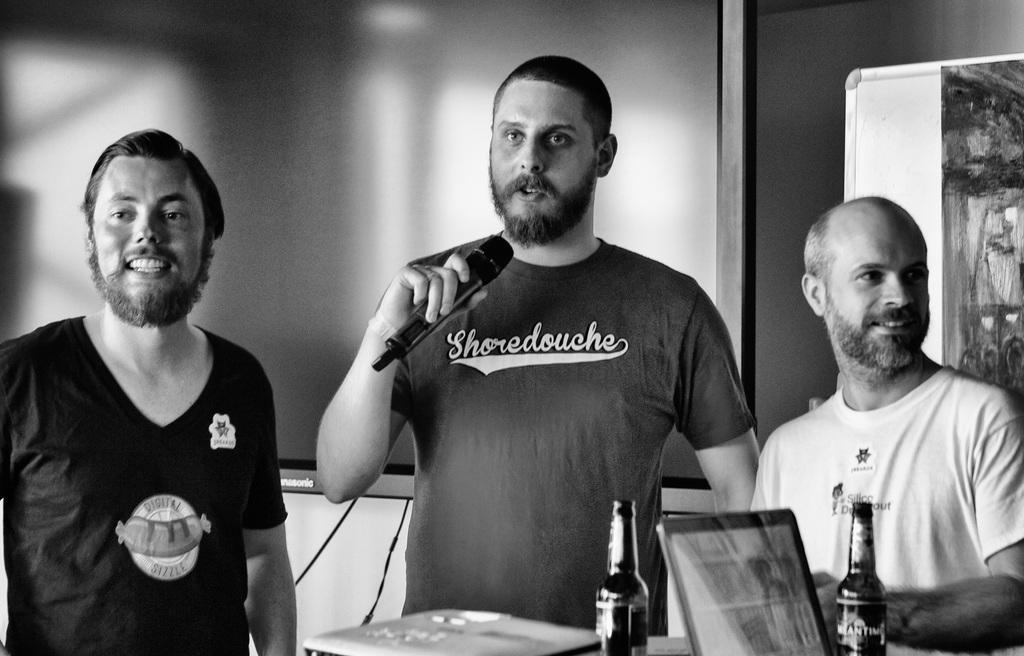Could you give a brief overview of what you see in this image? In this picture there is a man in the center of the image, by holding a mic in his hand and there are other people on the right and left side of the image, there is a table at the bottom side of the image, on which there are laptops and bottles, there is a board in the background area of the image. 